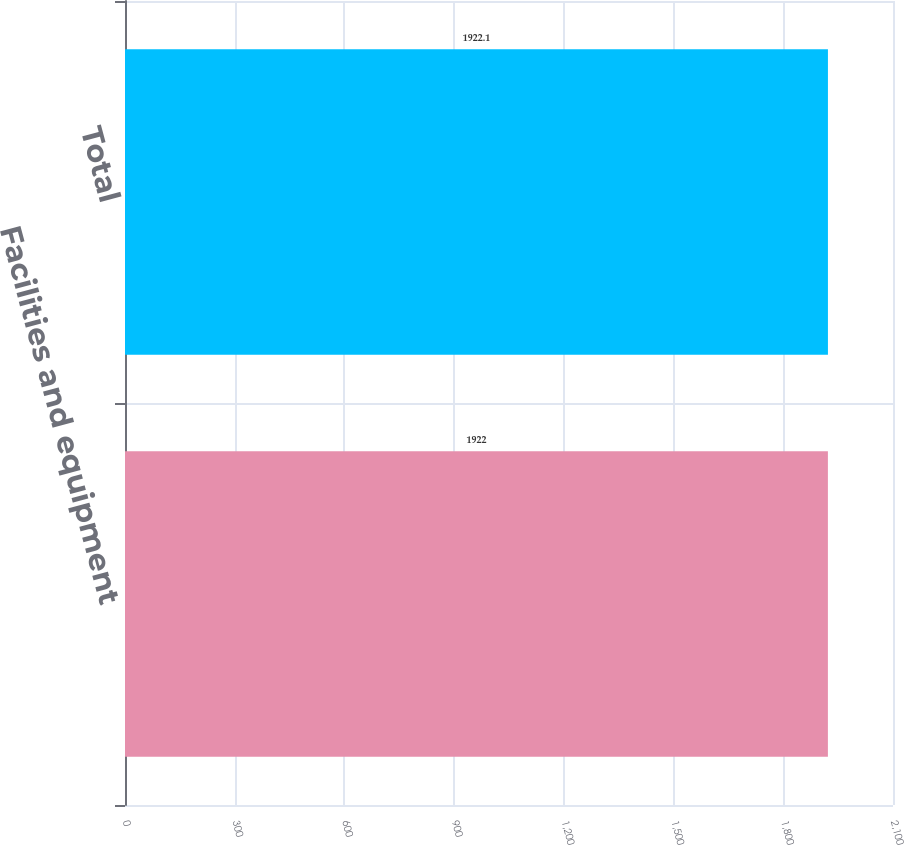<chart> <loc_0><loc_0><loc_500><loc_500><bar_chart><fcel>Facilities and equipment<fcel>Total<nl><fcel>1922<fcel>1922.1<nl></chart> 